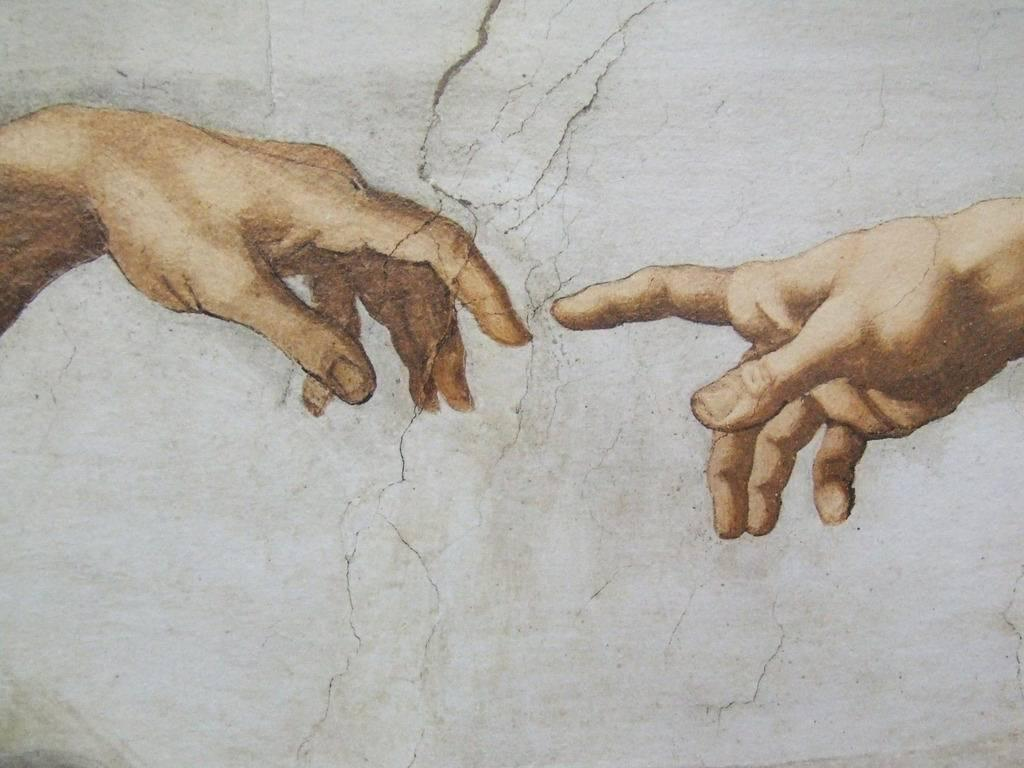What is depicted on the painting on the wall? There is a painting of a person's hand on the wall. What can be observed on the wall besides the painting? There are cracks on the wall. What direction is the shoe facing in the image? There is no shoe present in the image. 